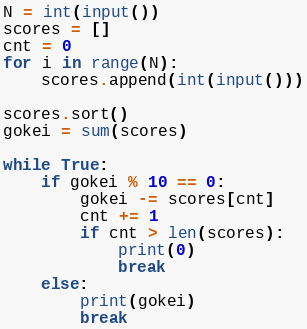Convert code to text. <code><loc_0><loc_0><loc_500><loc_500><_Python_>N = int(input())
scores = []
cnt = 0
for i in range(N):
    scores.append(int(input()))

scores.sort()
gokei = sum(scores)

while True:
    if gokei % 10 == 0:
        gokei -= scores[cnt]
        cnt += 1
        if cnt > len(scores):
            print(0)
            break
    else:
        print(gokei)
        break</code> 